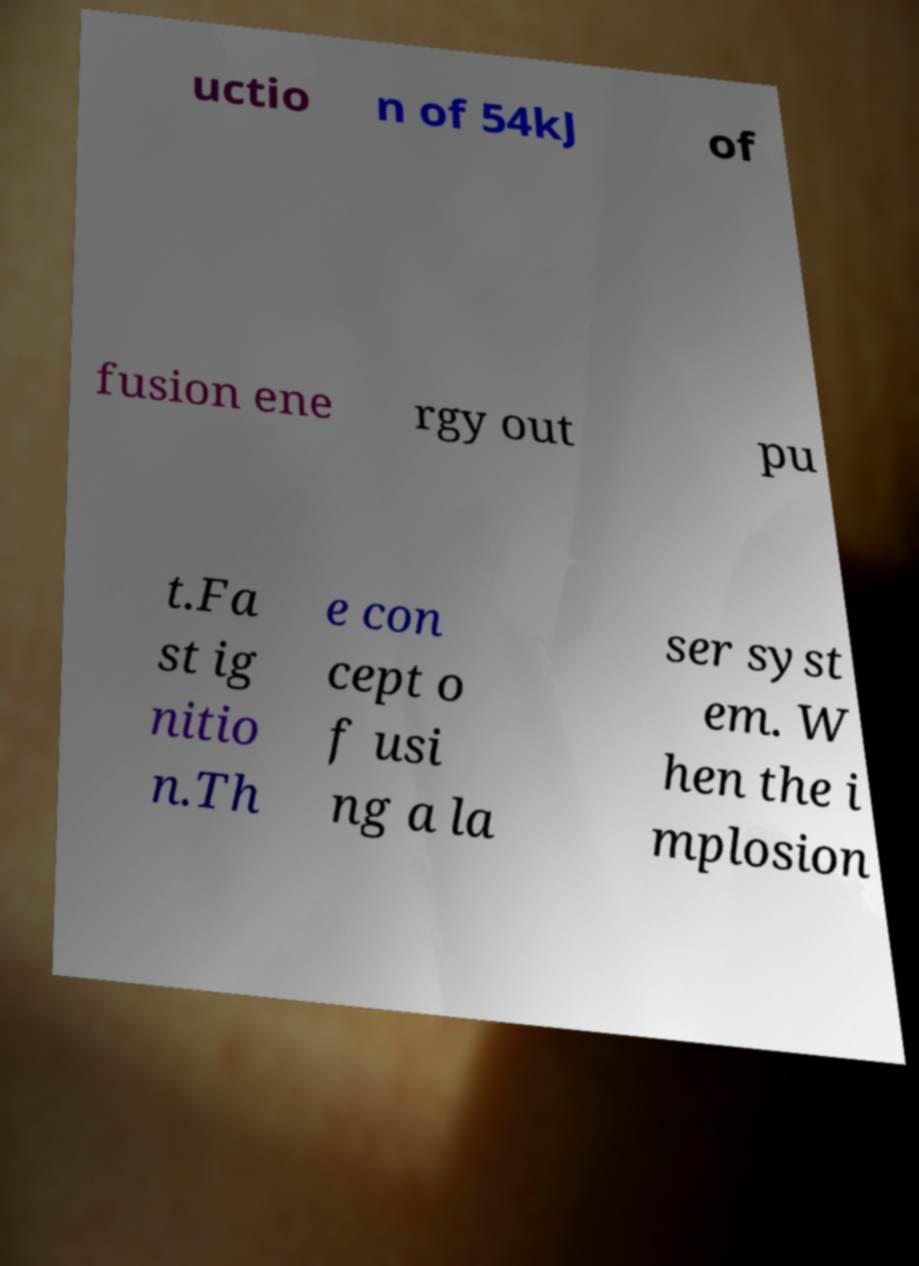Could you extract and type out the text from this image? uctio n of 54kJ of fusion ene rgy out pu t.Fa st ig nitio n.Th e con cept o f usi ng a la ser syst em. W hen the i mplosion 